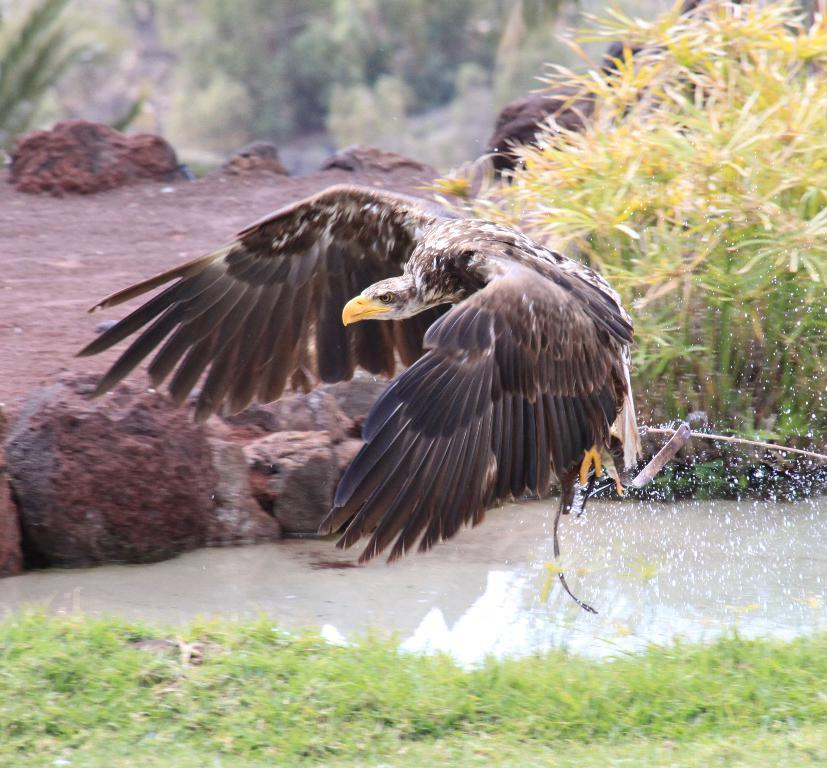What type of bird is in the image? There is a black eagle in the image. What type of terrain is visible in the image? There is grass and water visible in the image. What can be seen in the background of the image? There are plants visible in the background of the image. How would you describe the quality of the image? The image is slightly blurry in the background. What type of silk is being used by the vein in the image? There is no silk or vein present in the image; it features a black eagle in a natural setting. 